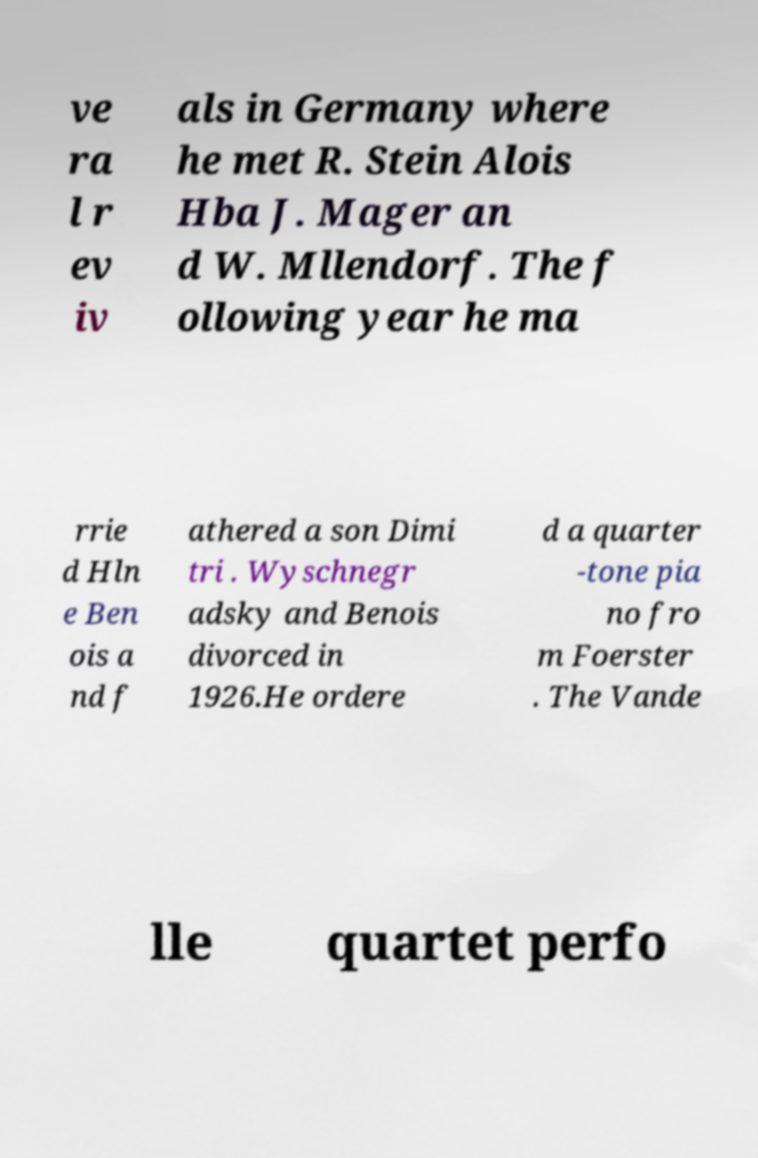Could you extract and type out the text from this image? ve ra l r ev iv als in Germany where he met R. Stein Alois Hba J. Mager an d W. Mllendorf. The f ollowing year he ma rrie d Hln e Ben ois a nd f athered a son Dimi tri . Wyschnegr adsky and Benois divorced in 1926.He ordere d a quarter -tone pia no fro m Foerster . The Vande lle quartet perfo 